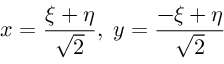<formula> <loc_0><loc_0><loc_500><loc_500>x = { \frac { \xi + \eta } { \sqrt { 2 } } } , \, y = { \frac { - \xi + \eta } { \sqrt { 2 } } }</formula> 